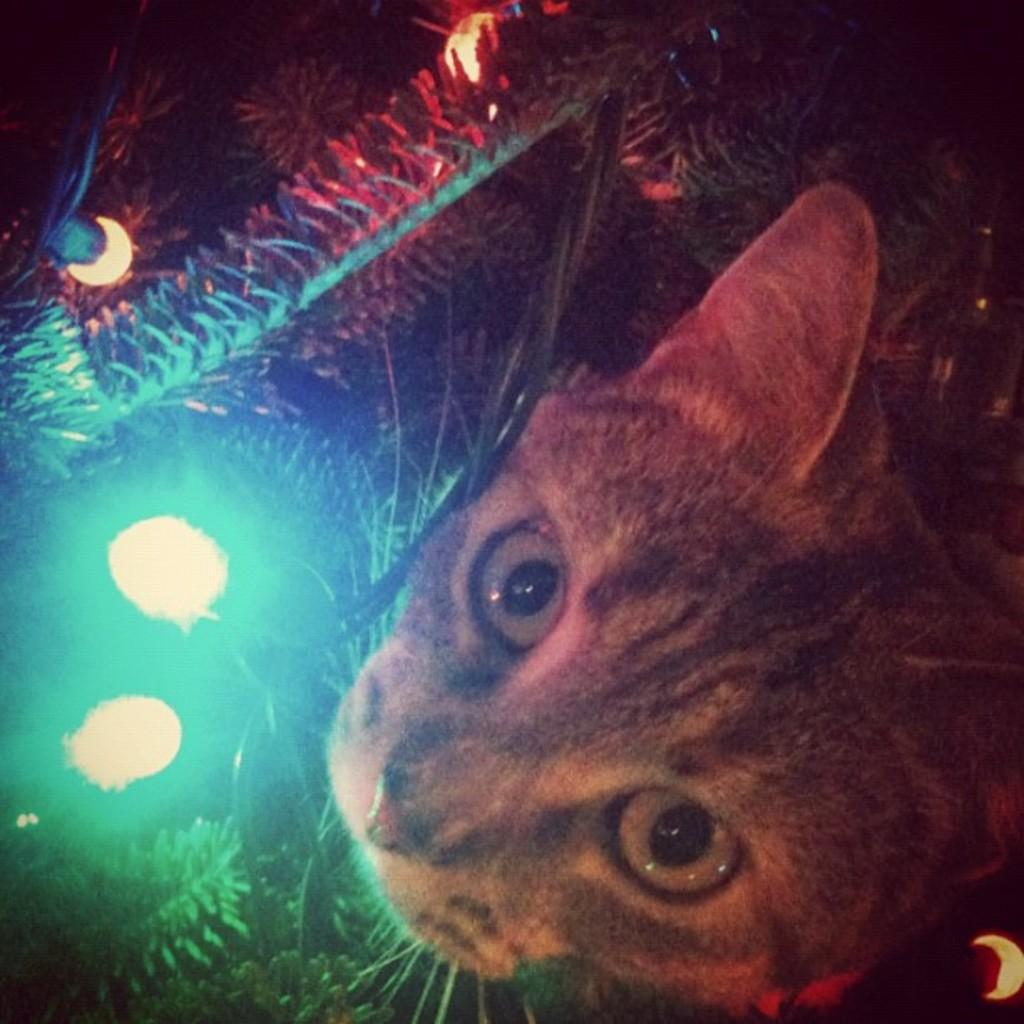What is the main subject of the image? The main subject of the image is a cat's face. What else can be seen in the image besides the cat's face? There are plants and lights visible in the image. Where is the bun located in the image? There is no bun present in the image. What type of scissors can be seen cutting the plants in the image? There are no scissors present in the image, and the plants are not being cut. 